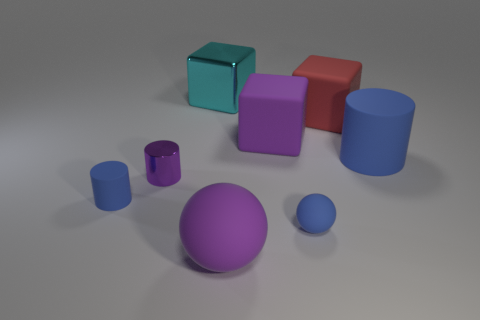Add 1 big metal blocks. How many objects exist? 9 Subtract all cubes. How many objects are left? 5 Add 5 big cyan blocks. How many big cyan blocks exist? 6 Subtract 1 blue spheres. How many objects are left? 7 Subtract all shiny cylinders. Subtract all cyan metallic things. How many objects are left? 6 Add 6 big blocks. How many big blocks are left? 9 